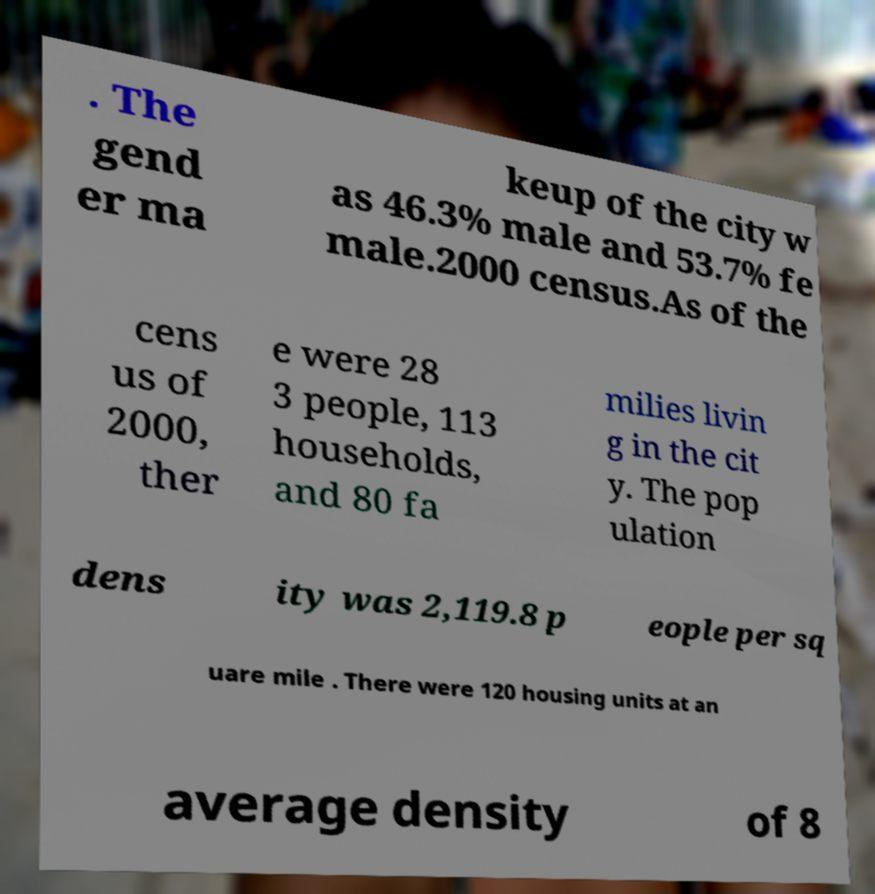Can you read and provide the text displayed in the image?This photo seems to have some interesting text. Can you extract and type it out for me? . The gend er ma keup of the city w as 46.3% male and 53.7% fe male.2000 census.As of the cens us of 2000, ther e were 28 3 people, 113 households, and 80 fa milies livin g in the cit y. The pop ulation dens ity was 2,119.8 p eople per sq uare mile . There were 120 housing units at an average density of 8 